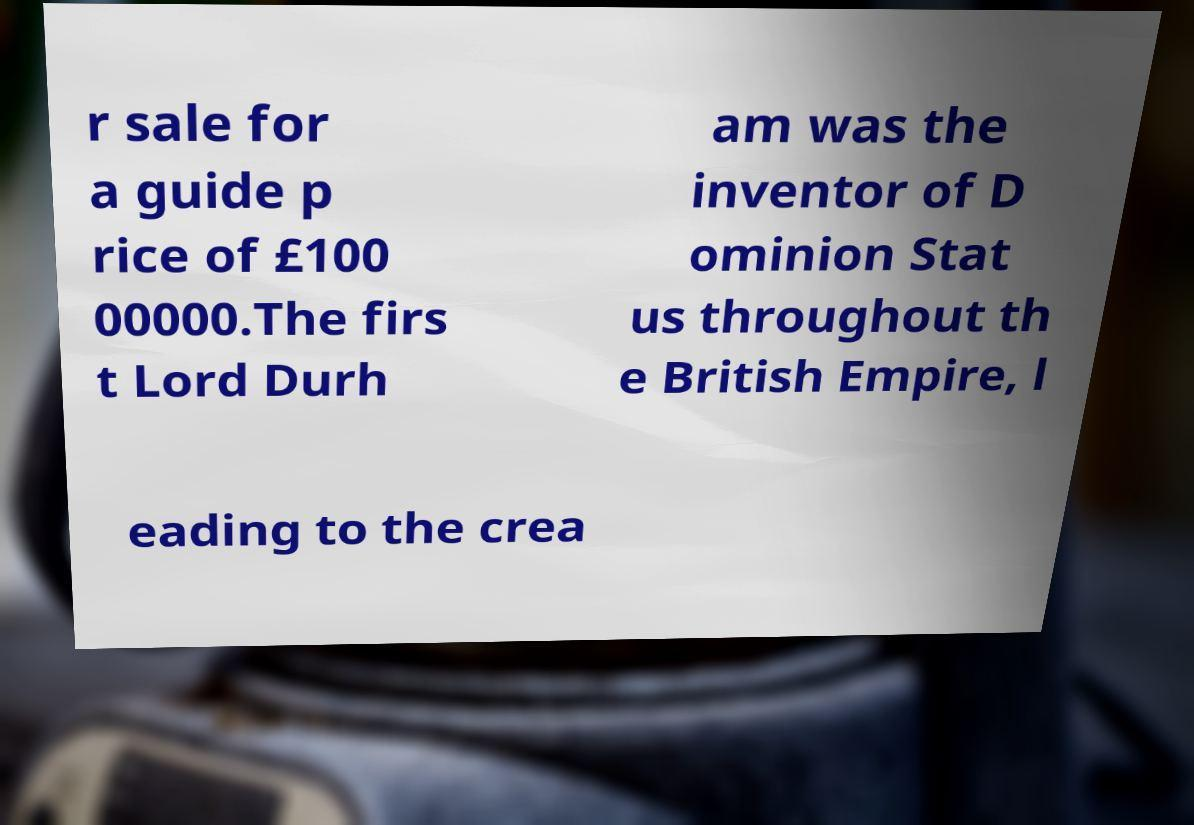Please read and relay the text visible in this image. What does it say? r sale for a guide p rice of £100 00000.The firs t Lord Durh am was the inventor of D ominion Stat us throughout th e British Empire, l eading to the crea 